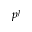<formula> <loc_0><loc_0><loc_500><loc_500>p ^ { j }</formula> 